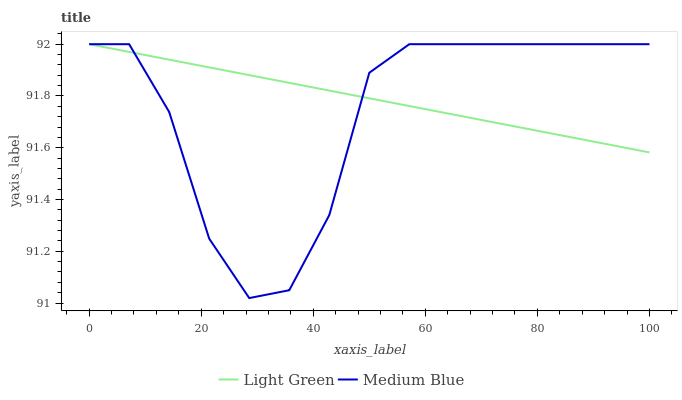Does Medium Blue have the minimum area under the curve?
Answer yes or no. Yes. Does Light Green have the maximum area under the curve?
Answer yes or no. Yes. Does Light Green have the minimum area under the curve?
Answer yes or no. No. Is Light Green the smoothest?
Answer yes or no. Yes. Is Medium Blue the roughest?
Answer yes or no. Yes. Is Light Green the roughest?
Answer yes or no. No. Does Medium Blue have the lowest value?
Answer yes or no. Yes. Does Light Green have the lowest value?
Answer yes or no. No. Does Light Green have the highest value?
Answer yes or no. Yes. Does Light Green intersect Medium Blue?
Answer yes or no. Yes. Is Light Green less than Medium Blue?
Answer yes or no. No. Is Light Green greater than Medium Blue?
Answer yes or no. No. 